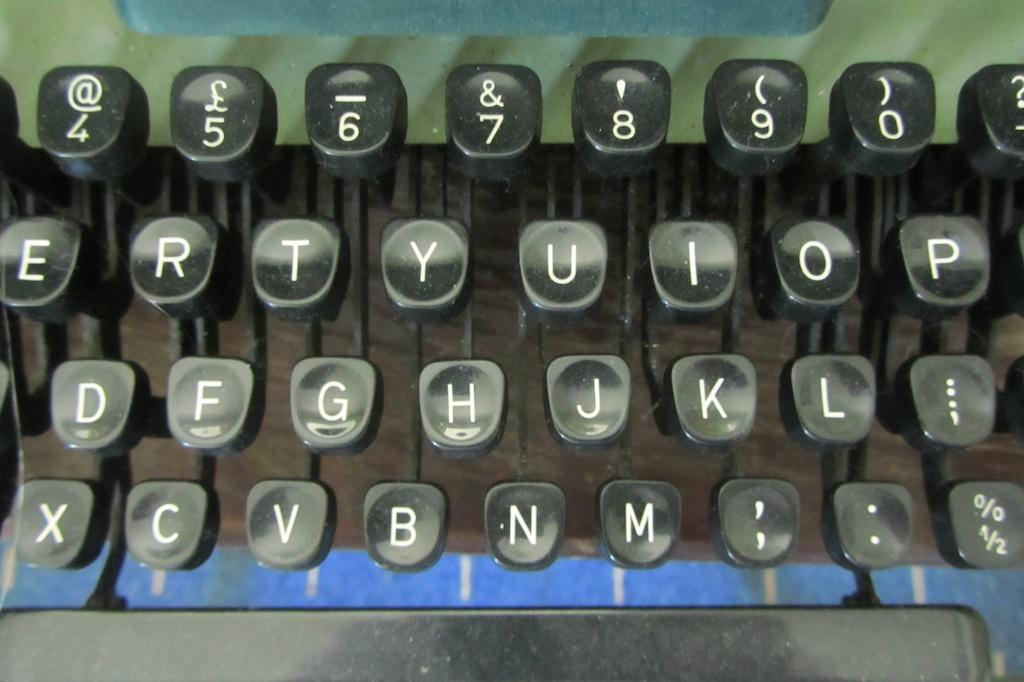<image>
Write a terse but informative summary of the picture. many numbers on a typewriter that are black and white 